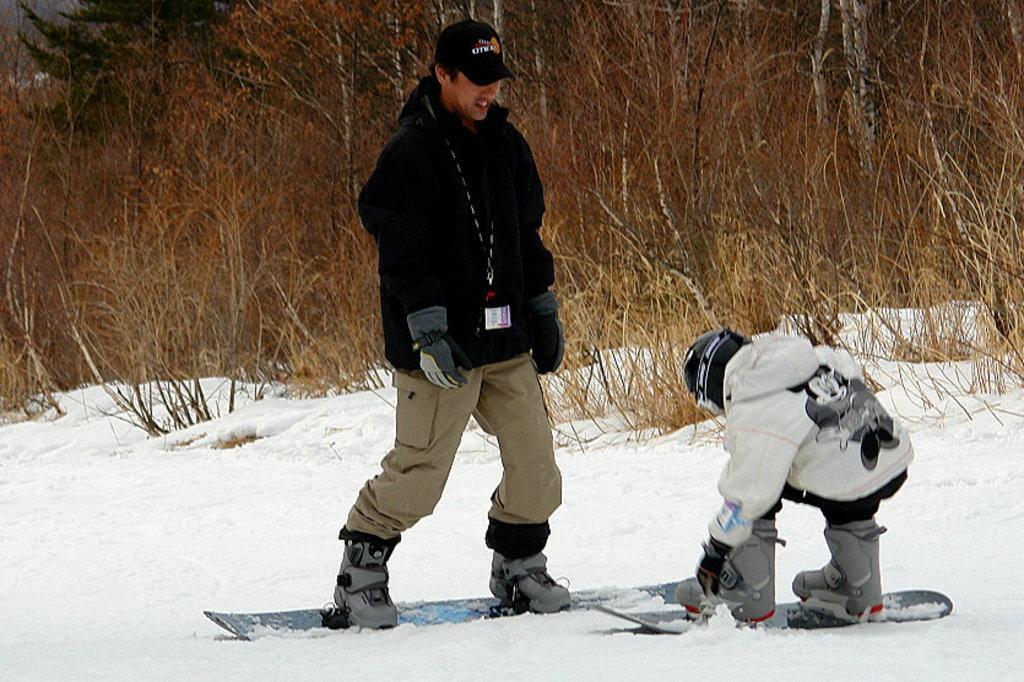How would you summarize this image in a sentence or two? In this picture,there is a man who is wearing a black jacket and a black cap. He is wearing gloves on his hands. He is on ski. There is a child who is wearing a helmet and white jacket. On his white jacket,there is an image of mickey mouse. This boy is also on the ski. There is a snow and there are some trees at the background. 